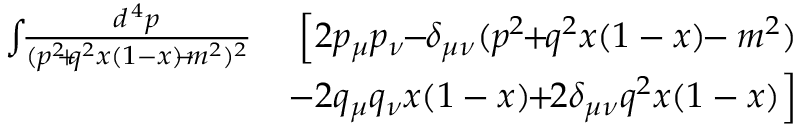<formula> <loc_0><loc_0><loc_500><loc_500>\begin{array} { r l r } { \int \, { \frac { d ^ { \, 4 } p } { ( p ^ { 2 } \, + \, q ^ { 2 } x ( 1 - x ) \, - \, m ^ { 2 } ) ^ { 2 } } } } & { \, \left [ 2 p _ { \mu } p _ { \nu } \, - \, \delta _ { \mu \nu } ( p ^ { 2 } \, + \, q ^ { 2 } x ( 1 - x ) \, - m ^ { 2 } ) } \\ & { \, - 2 q _ { \mu } q _ { \nu } x ( 1 - x ) \, + \, 2 \delta _ { \mu \nu } q ^ { 2 } x ( 1 - x ) \right ] } \end{array}</formula> 